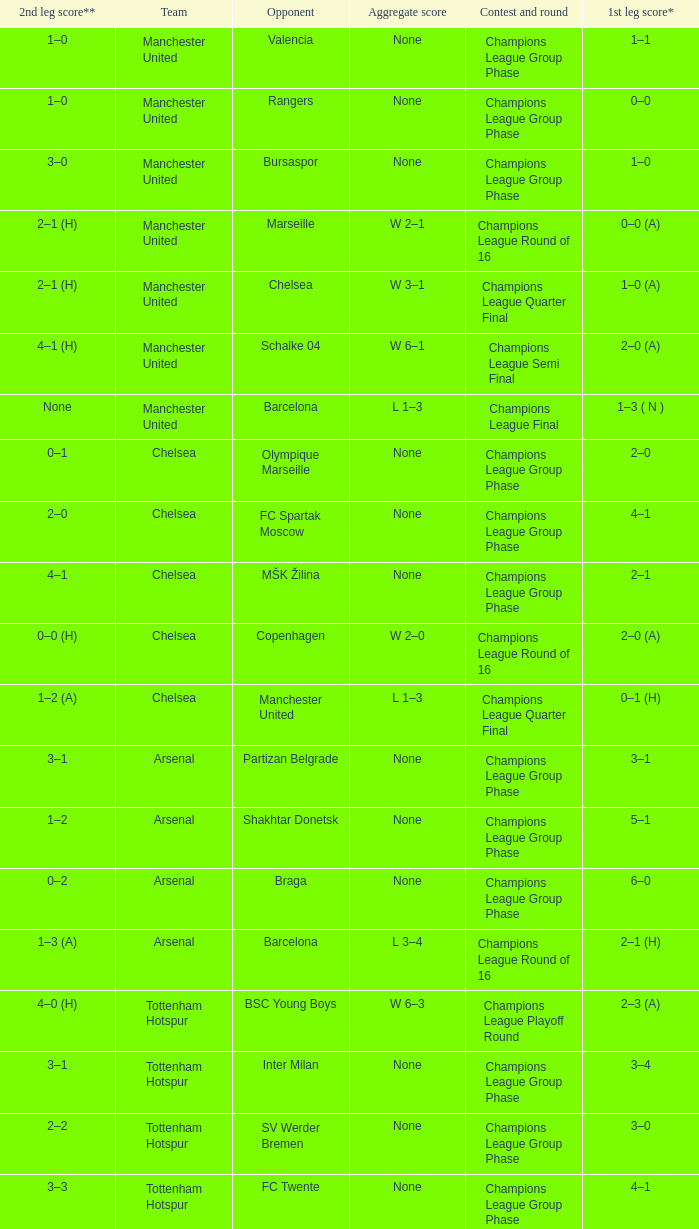Could you parse the entire table? {'header': ['2nd leg score**', 'Team', 'Opponent', 'Aggregate score', 'Contest and round', '1st leg score*'], 'rows': [['1–0', 'Manchester United', 'Valencia', 'None', 'Champions League Group Phase', '1–1'], ['1–0', 'Manchester United', 'Rangers', 'None', 'Champions League Group Phase', '0–0'], ['3–0', 'Manchester United', 'Bursaspor', 'None', 'Champions League Group Phase', '1–0'], ['2–1 (H)', 'Manchester United', 'Marseille', 'W 2–1', 'Champions League Round of 16', '0–0 (A)'], ['2–1 (H)', 'Manchester United', 'Chelsea', 'W 3–1', 'Champions League Quarter Final', '1–0 (A)'], ['4–1 (H)', 'Manchester United', 'Schalke 04', 'W 6–1', 'Champions League Semi Final', '2–0 (A)'], ['None', 'Manchester United', 'Barcelona', 'L 1–3', 'Champions League Final', '1–3 ( N )'], ['0–1', 'Chelsea', 'Olympique Marseille', 'None', 'Champions League Group Phase', '2–0'], ['2–0', 'Chelsea', 'FC Spartak Moscow', 'None', 'Champions League Group Phase', '4–1'], ['4–1', 'Chelsea', 'MŠK Žilina', 'None', 'Champions League Group Phase', '2–1'], ['0–0 (H)', 'Chelsea', 'Copenhagen', 'W 2–0', 'Champions League Round of 16', '2–0 (A)'], ['1–2 (A)', 'Chelsea', 'Manchester United', 'L 1–3', 'Champions League Quarter Final', '0–1 (H)'], ['3–1', 'Arsenal', 'Partizan Belgrade', 'None', 'Champions League Group Phase', '3–1'], ['1–2', 'Arsenal', 'Shakhtar Donetsk', 'None', 'Champions League Group Phase', '5–1'], ['0–2', 'Arsenal', 'Braga', 'None', 'Champions League Group Phase', '6–0'], ['1–3 (A)', 'Arsenal', 'Barcelona', 'L 3–4', 'Champions League Round of 16', '2–1 (H)'], ['4–0 (H)', 'Tottenham Hotspur', 'BSC Young Boys', 'W 6–3', 'Champions League Playoff Round', '2–3 (A)'], ['3–1', 'Tottenham Hotspur', 'Inter Milan', 'None', 'Champions League Group Phase', '3–4'], ['2–2', 'Tottenham Hotspur', 'SV Werder Bremen', 'None', 'Champions League Group Phase', '3–0'], ['3–3', 'Tottenham Hotspur', 'FC Twente', 'None', 'Champions League Group Phase', '4–1'], ['0–0 (H)', 'Tottenham Hotspur', 'A.C. Milan', 'W 1–0', 'Champions League Round of 16', '1–0 (A)'], ['0–1 (H)', 'Tottenham Hotspur', 'Real Madrid', 'L 0–5', 'Champions League Quarter Final', '0–4 (A)'], ['2–0 (H)', 'Manchester City', 'FC Timişoara', 'W 3–0', 'Europa League Playoff Round', '1–0 (A)'], ['1–1', 'Manchester City', 'Juventus', 'None', 'Europa League Group Phase', '1–1'], ['1–3', 'Manchester City', 'Lech Poznań', 'None', 'Europa League Group Phase', '3–1'], ['2–0', 'Manchester City', 'Red Bull Salzburg', 'None', 'Europa League Group Phase', '3–0'], ['3–0 (H)', 'Manchester City', 'Aris', 'W 3–0', 'Europa League Round of 32', '0–0 (A)'], ['1–0 (H)', 'Manchester City', 'Dynamio Kyiv', 'L 1–2', 'Europa League Round of 16', '0–2 (A)'], ['2–3 (H)', 'Aston Villa', 'SK Rapid Wien', 'L 3–4', 'Europa League Playoff Round', '1–1 (A)'], ['2–0 (H)', 'Liverpool', 'FK Rabotnički', 'W 4–0', 'Europa League 3rd Qual. Round', '2–0 (A)'], ['2–1 (A)', 'Liverpool', 'Trabzonspor', 'W 3–1', 'Europa League Playoff Round', '1–0 (H)'], ['0–0', 'Liverpool', 'Napoli', 'None', 'Europa League Group Phase', '3–1'], ['1–1', 'Liverpool', 'Steaua Bucureşti', 'None', 'Europa League Group Phase', '4–1'], ['0–0', 'Liverpool', 'Utrecht', 'None', 'Europa League Group Phase', '0–0'], ['1–0 (H)', 'Liverpool', 'Sparta Prague', 'W 1–0', 'Europa League Round of 32', '0–0 (A)']]} What was the score between Marseille and Manchester United on the second leg of the Champions League Round of 16? 2–1 (H). 